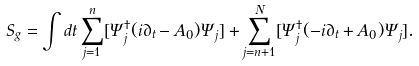<formula> <loc_0><loc_0><loc_500><loc_500>S _ { g } = \int d t \sum _ { j = 1 } ^ { n } [ \Psi _ { j } ^ { \dagger } ( i \partial _ { t } - A _ { 0 } ) \Psi _ { j } ] + \sum _ { j = n + 1 } ^ { N } [ \Psi _ { j } ^ { \dagger } ( - i \partial _ { t } + A _ { 0 } ) \Psi _ { j } ] .</formula> 